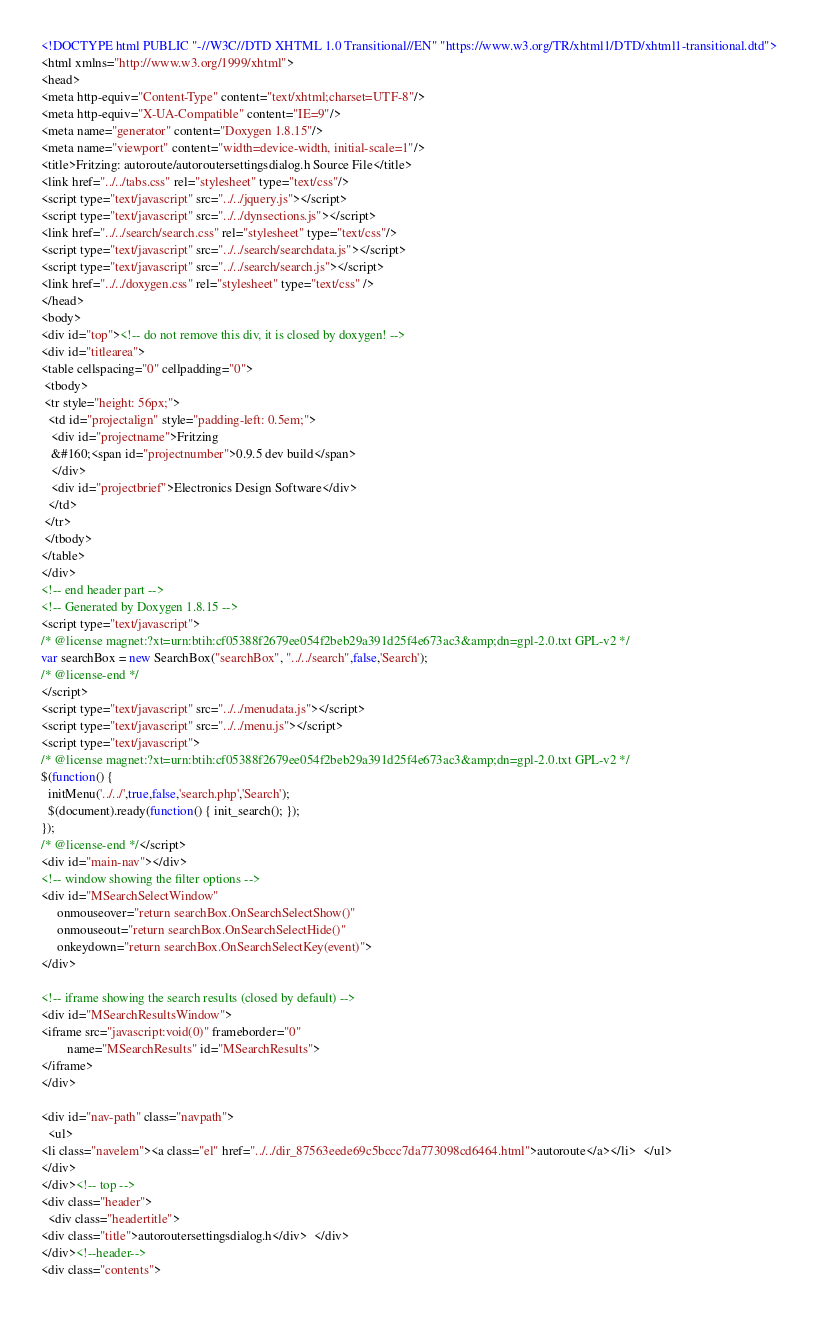<code> <loc_0><loc_0><loc_500><loc_500><_HTML_><!DOCTYPE html PUBLIC "-//W3C//DTD XHTML 1.0 Transitional//EN" "https://www.w3.org/TR/xhtml1/DTD/xhtml1-transitional.dtd">
<html xmlns="http://www.w3.org/1999/xhtml">
<head>
<meta http-equiv="Content-Type" content="text/xhtml;charset=UTF-8"/>
<meta http-equiv="X-UA-Compatible" content="IE=9"/>
<meta name="generator" content="Doxygen 1.8.15"/>
<meta name="viewport" content="width=device-width, initial-scale=1"/>
<title>Fritzing: autoroute/autoroutersettingsdialog.h Source File</title>
<link href="../../tabs.css" rel="stylesheet" type="text/css"/>
<script type="text/javascript" src="../../jquery.js"></script>
<script type="text/javascript" src="../../dynsections.js"></script>
<link href="../../search/search.css" rel="stylesheet" type="text/css"/>
<script type="text/javascript" src="../../search/searchdata.js"></script>
<script type="text/javascript" src="../../search/search.js"></script>
<link href="../../doxygen.css" rel="stylesheet" type="text/css" />
</head>
<body>
<div id="top"><!-- do not remove this div, it is closed by doxygen! -->
<div id="titlearea">
<table cellspacing="0" cellpadding="0">
 <tbody>
 <tr style="height: 56px;">
  <td id="projectalign" style="padding-left: 0.5em;">
   <div id="projectname">Fritzing
   &#160;<span id="projectnumber">0.9.5 dev build</span>
   </div>
   <div id="projectbrief">Electronics Design Software</div>
  </td>
 </tr>
 </tbody>
</table>
</div>
<!-- end header part -->
<!-- Generated by Doxygen 1.8.15 -->
<script type="text/javascript">
/* @license magnet:?xt=urn:btih:cf05388f2679ee054f2beb29a391d25f4e673ac3&amp;dn=gpl-2.0.txt GPL-v2 */
var searchBox = new SearchBox("searchBox", "../../search",false,'Search');
/* @license-end */
</script>
<script type="text/javascript" src="../../menudata.js"></script>
<script type="text/javascript" src="../../menu.js"></script>
<script type="text/javascript">
/* @license magnet:?xt=urn:btih:cf05388f2679ee054f2beb29a391d25f4e673ac3&amp;dn=gpl-2.0.txt GPL-v2 */
$(function() {
  initMenu('../../',true,false,'search.php','Search');
  $(document).ready(function() { init_search(); });
});
/* @license-end */</script>
<div id="main-nav"></div>
<!-- window showing the filter options -->
<div id="MSearchSelectWindow"
     onmouseover="return searchBox.OnSearchSelectShow()"
     onmouseout="return searchBox.OnSearchSelectHide()"
     onkeydown="return searchBox.OnSearchSelectKey(event)">
</div>

<!-- iframe showing the search results (closed by default) -->
<div id="MSearchResultsWindow">
<iframe src="javascript:void(0)" frameborder="0" 
        name="MSearchResults" id="MSearchResults">
</iframe>
</div>

<div id="nav-path" class="navpath">
  <ul>
<li class="navelem"><a class="el" href="../../dir_87563eede69c5bccc7da773098cd6464.html">autoroute</a></li>  </ul>
</div>
</div><!-- top -->
<div class="header">
  <div class="headertitle">
<div class="title">autoroutersettingsdialog.h</div>  </div>
</div><!--header-->
<div class="contents"></code> 